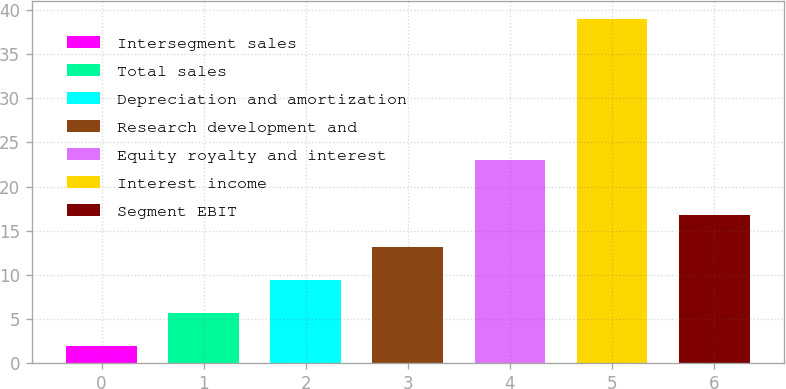Convert chart. <chart><loc_0><loc_0><loc_500><loc_500><bar_chart><fcel>Intersegment sales<fcel>Total sales<fcel>Depreciation and amortization<fcel>Research development and<fcel>Equity royalty and interest<fcel>Interest income<fcel>Segment EBIT<nl><fcel>2<fcel>5.7<fcel>9.4<fcel>13.1<fcel>23<fcel>39<fcel>16.8<nl></chart> 